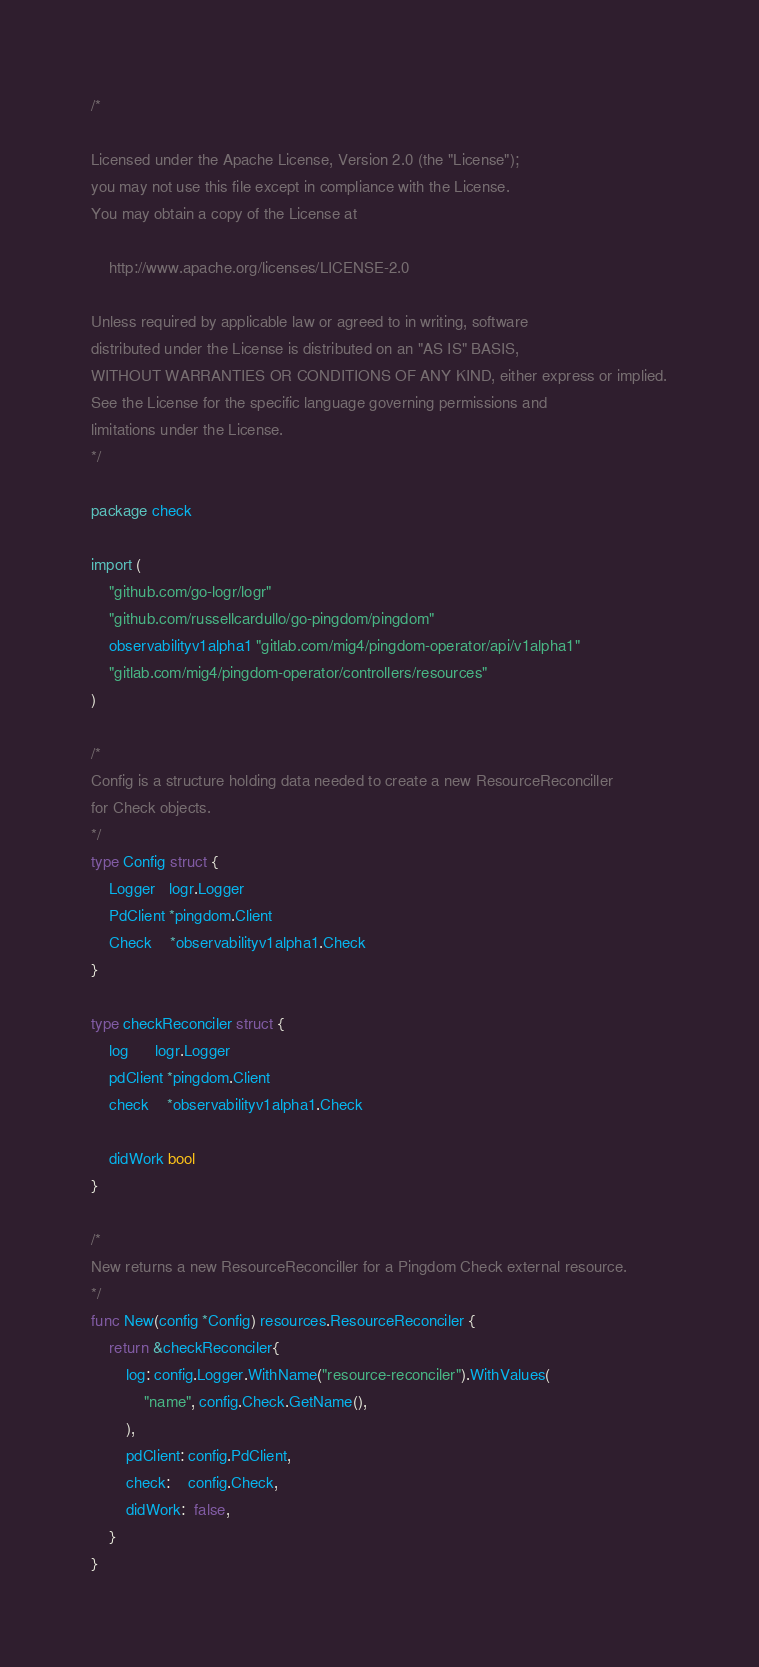<code> <loc_0><loc_0><loc_500><loc_500><_Go_>/*

Licensed under the Apache License, Version 2.0 (the "License");
you may not use this file except in compliance with the License.
You may obtain a copy of the License at

    http://www.apache.org/licenses/LICENSE-2.0

Unless required by applicable law or agreed to in writing, software
distributed under the License is distributed on an "AS IS" BASIS,
WITHOUT WARRANTIES OR CONDITIONS OF ANY KIND, either express or implied.
See the License for the specific language governing permissions and
limitations under the License.
*/

package check

import (
	"github.com/go-logr/logr"
	"github.com/russellcardullo/go-pingdom/pingdom"
	observabilityv1alpha1 "gitlab.com/mig4/pingdom-operator/api/v1alpha1"
	"gitlab.com/mig4/pingdom-operator/controllers/resources"
)

/*
Config is a structure holding data needed to create a new ResourceReconciller
for Check objects.
*/
type Config struct {
	Logger   logr.Logger
	PdClient *pingdom.Client
	Check    *observabilityv1alpha1.Check
}

type checkReconciler struct {
	log      logr.Logger
	pdClient *pingdom.Client
	check    *observabilityv1alpha1.Check

	didWork bool
}

/*
New returns a new ResourceReconciller for a Pingdom Check external resource.
*/
func New(config *Config) resources.ResourceReconciler {
	return &checkReconciler{
		log: config.Logger.WithName("resource-reconciler").WithValues(
			"name", config.Check.GetName(),
		),
		pdClient: config.PdClient,
		check:    config.Check,
		didWork:  false,
	}
}
</code> 